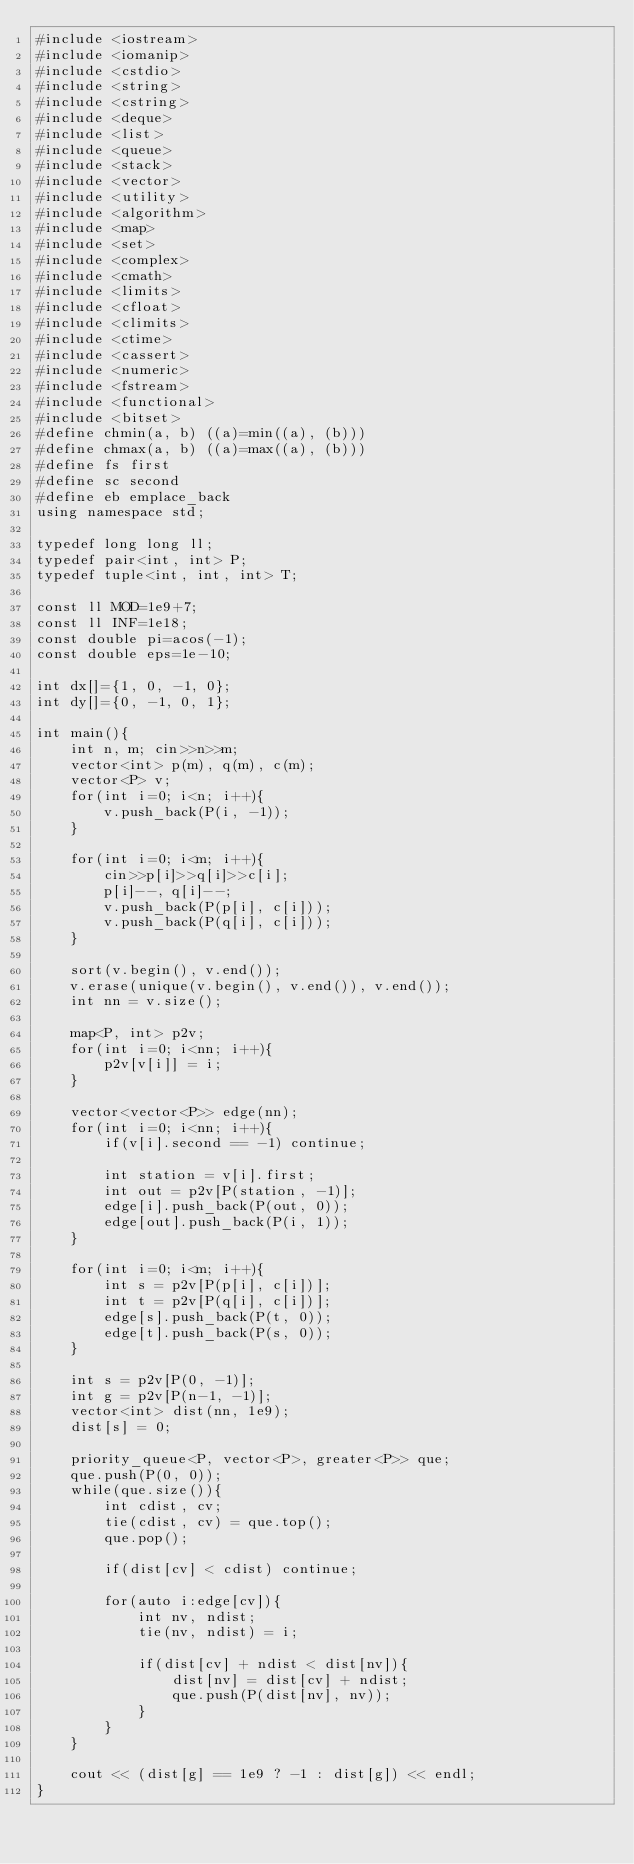<code> <loc_0><loc_0><loc_500><loc_500><_C++_>#include <iostream>
#include <iomanip>
#include <cstdio>
#include <string>
#include <cstring>
#include <deque>
#include <list>
#include <queue>
#include <stack>
#include <vector>
#include <utility>
#include <algorithm>
#include <map>
#include <set>
#include <complex>
#include <cmath>
#include <limits>
#include <cfloat>
#include <climits>
#include <ctime>
#include <cassert>
#include <numeric>
#include <fstream>
#include <functional>
#include <bitset>
#define chmin(a, b) ((a)=min((a), (b)))
#define chmax(a, b) ((a)=max((a), (b)))
#define fs first
#define sc second
#define eb emplace_back
using namespace std;

typedef long long ll;
typedef pair<int, int> P;
typedef tuple<int, int, int> T;

const ll MOD=1e9+7;
const ll INF=1e18;
const double pi=acos(-1);
const double eps=1e-10;

int dx[]={1, 0, -1, 0};
int dy[]={0, -1, 0, 1};

int main(){
    int n, m; cin>>n>>m;
    vector<int> p(m), q(m), c(m);
    vector<P> v;
    for(int i=0; i<n; i++){
        v.push_back(P(i, -1));
    }

    for(int i=0; i<m; i++){
        cin>>p[i]>>q[i]>>c[i];
        p[i]--, q[i]--;
        v.push_back(P(p[i], c[i]));
        v.push_back(P(q[i], c[i]));
    }

    sort(v.begin(), v.end());
    v.erase(unique(v.begin(), v.end()), v.end());
    int nn = v.size();

    map<P, int> p2v;
    for(int i=0; i<nn; i++){
        p2v[v[i]] = i;
    }

    vector<vector<P>> edge(nn);
    for(int i=0; i<nn; i++){
        if(v[i].second == -1) continue;

        int station = v[i].first;
        int out = p2v[P(station, -1)];
        edge[i].push_back(P(out, 0));
        edge[out].push_back(P(i, 1));
    }

    for(int i=0; i<m; i++){
        int s = p2v[P(p[i], c[i])];
        int t = p2v[P(q[i], c[i])];
        edge[s].push_back(P(t, 0));
        edge[t].push_back(P(s, 0));
    }

    int s = p2v[P(0, -1)];
    int g = p2v[P(n-1, -1)];
    vector<int> dist(nn, 1e9);
    dist[s] = 0;

    priority_queue<P, vector<P>, greater<P>> que;
    que.push(P(0, 0));
    while(que.size()){
        int cdist, cv;
        tie(cdist, cv) = que.top();
        que.pop();

        if(dist[cv] < cdist) continue;

        for(auto i:edge[cv]){
            int nv, ndist;
            tie(nv, ndist) = i;

            if(dist[cv] + ndist < dist[nv]){
                dist[nv] = dist[cv] + ndist;
                que.push(P(dist[nv], nv));
            }
        }
    }

    cout << (dist[g] == 1e9 ? -1 : dist[g]) << endl;
}</code> 